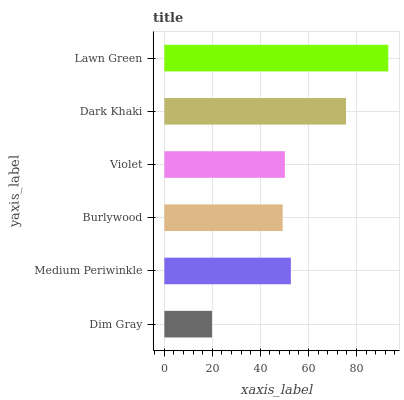Is Dim Gray the minimum?
Answer yes or no. Yes. Is Lawn Green the maximum?
Answer yes or no. Yes. Is Medium Periwinkle the minimum?
Answer yes or no. No. Is Medium Periwinkle the maximum?
Answer yes or no. No. Is Medium Periwinkle greater than Dim Gray?
Answer yes or no. Yes. Is Dim Gray less than Medium Periwinkle?
Answer yes or no. Yes. Is Dim Gray greater than Medium Periwinkle?
Answer yes or no. No. Is Medium Periwinkle less than Dim Gray?
Answer yes or no. No. Is Medium Periwinkle the high median?
Answer yes or no. Yes. Is Violet the low median?
Answer yes or no. Yes. Is Violet the high median?
Answer yes or no. No. Is Medium Periwinkle the low median?
Answer yes or no. No. 